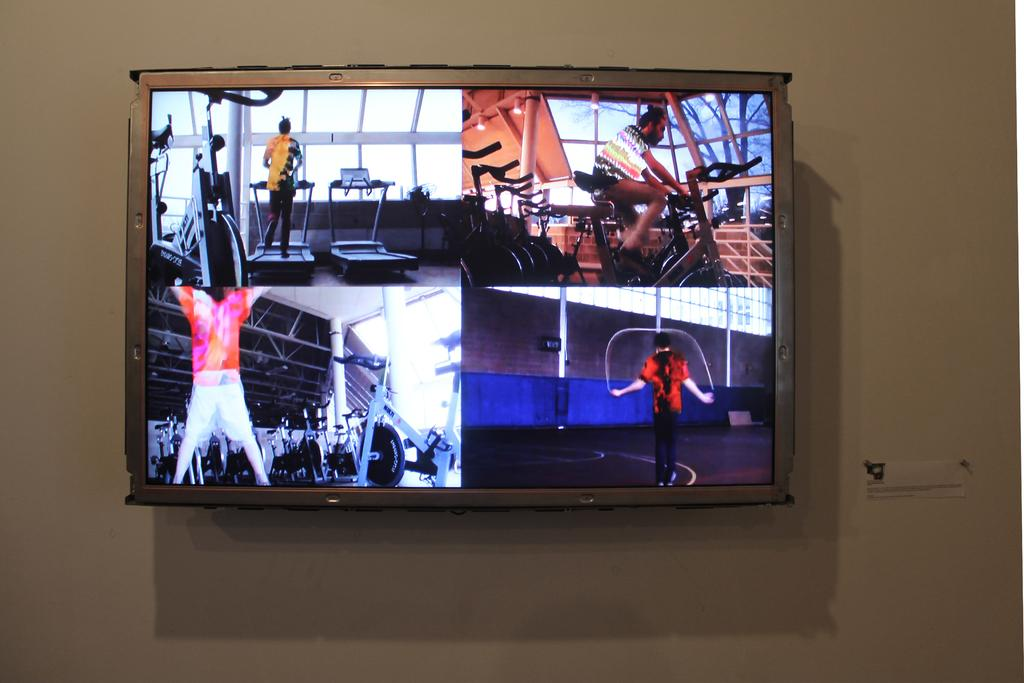What is mounted on the wall in the image? There is a television on the wall. What is being displayed on the television screen? People are doing exercise on the screen of the television. What type of health guide is being shown on the television screen? There is no health guide present in the image; the television screen displays people doing exercise. 